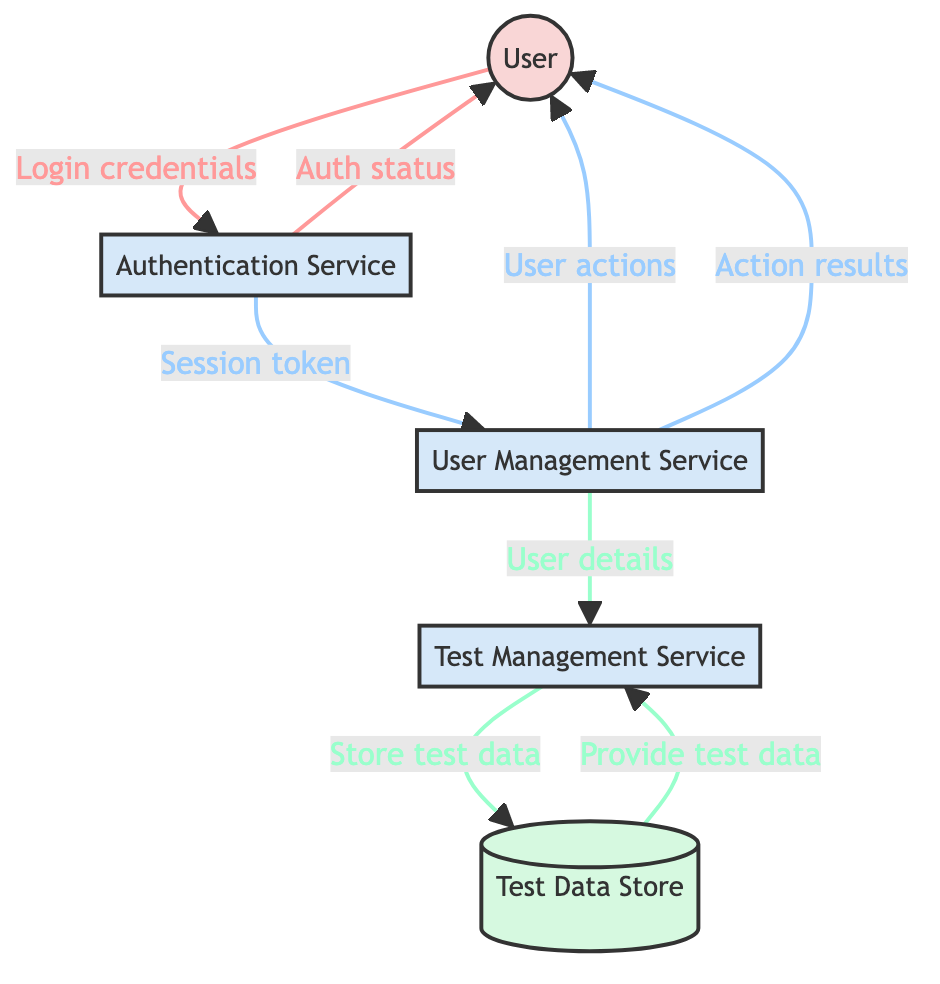What's the total number of entities in the diagram? The diagram lists five entities: User, Authentication Service, User Management Service, Test Management Service, and Test Data Store. Therefore, the total number is five.
Answer: 5 What is the source of the data flow labeled "Returns authentication status"? The flow labeled "Returns authentication status" originates from the Authentication Service, which responds to the User after processing the login request.
Answer: Authentication Service What action does the User Management Service perform after receiving the session token? After receiving the session token, the User Management Service returns user management actions such as create, update, and delete to the User, allowing them to manage their account.
Answer: Returns user management actions How many data flows are there in total? The diagram shows a total of eight data flows connecting various entities, detailing interactions and information exchanges between them.
Answer: 8 Which entity is responsible for managing the user login process? The Authentication Service is specifically responsible for managing user login and authentication, processing the credentials submitted by the User.
Answer: Authentication Service What type of interaction does the Test Management Service have with the Test Data Store? The Test Management Service stores test cases and results in the Test Data Store and also queries it to provide test cases and results when needed.
Answer: Stores test data What type of information flows from the User Management Service to the Test Management Service? The User Management Service sends user details to the Test Management Service, which helps in assigning and managing tests for those users.
Answer: User details How many processes are represented in the diagram? The diagram contains four processes: Authentication Service, User Management Service, Test Management Service, and Test Data Store.
Answer: 4 What does the data flow from the Test Data Store to the Test Management Service provide? The data flow from the Test Data Store to the Test Management Service provides test cases and results when queried by the Test Management Service.
Answer: Provides test cases and results 